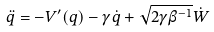<formula> <loc_0><loc_0><loc_500><loc_500>\ddot { q } = - V ^ { \prime } ( q ) - \gamma \dot { q } + \sqrt { 2 \gamma \beta ^ { - 1 } } \dot { W }</formula> 